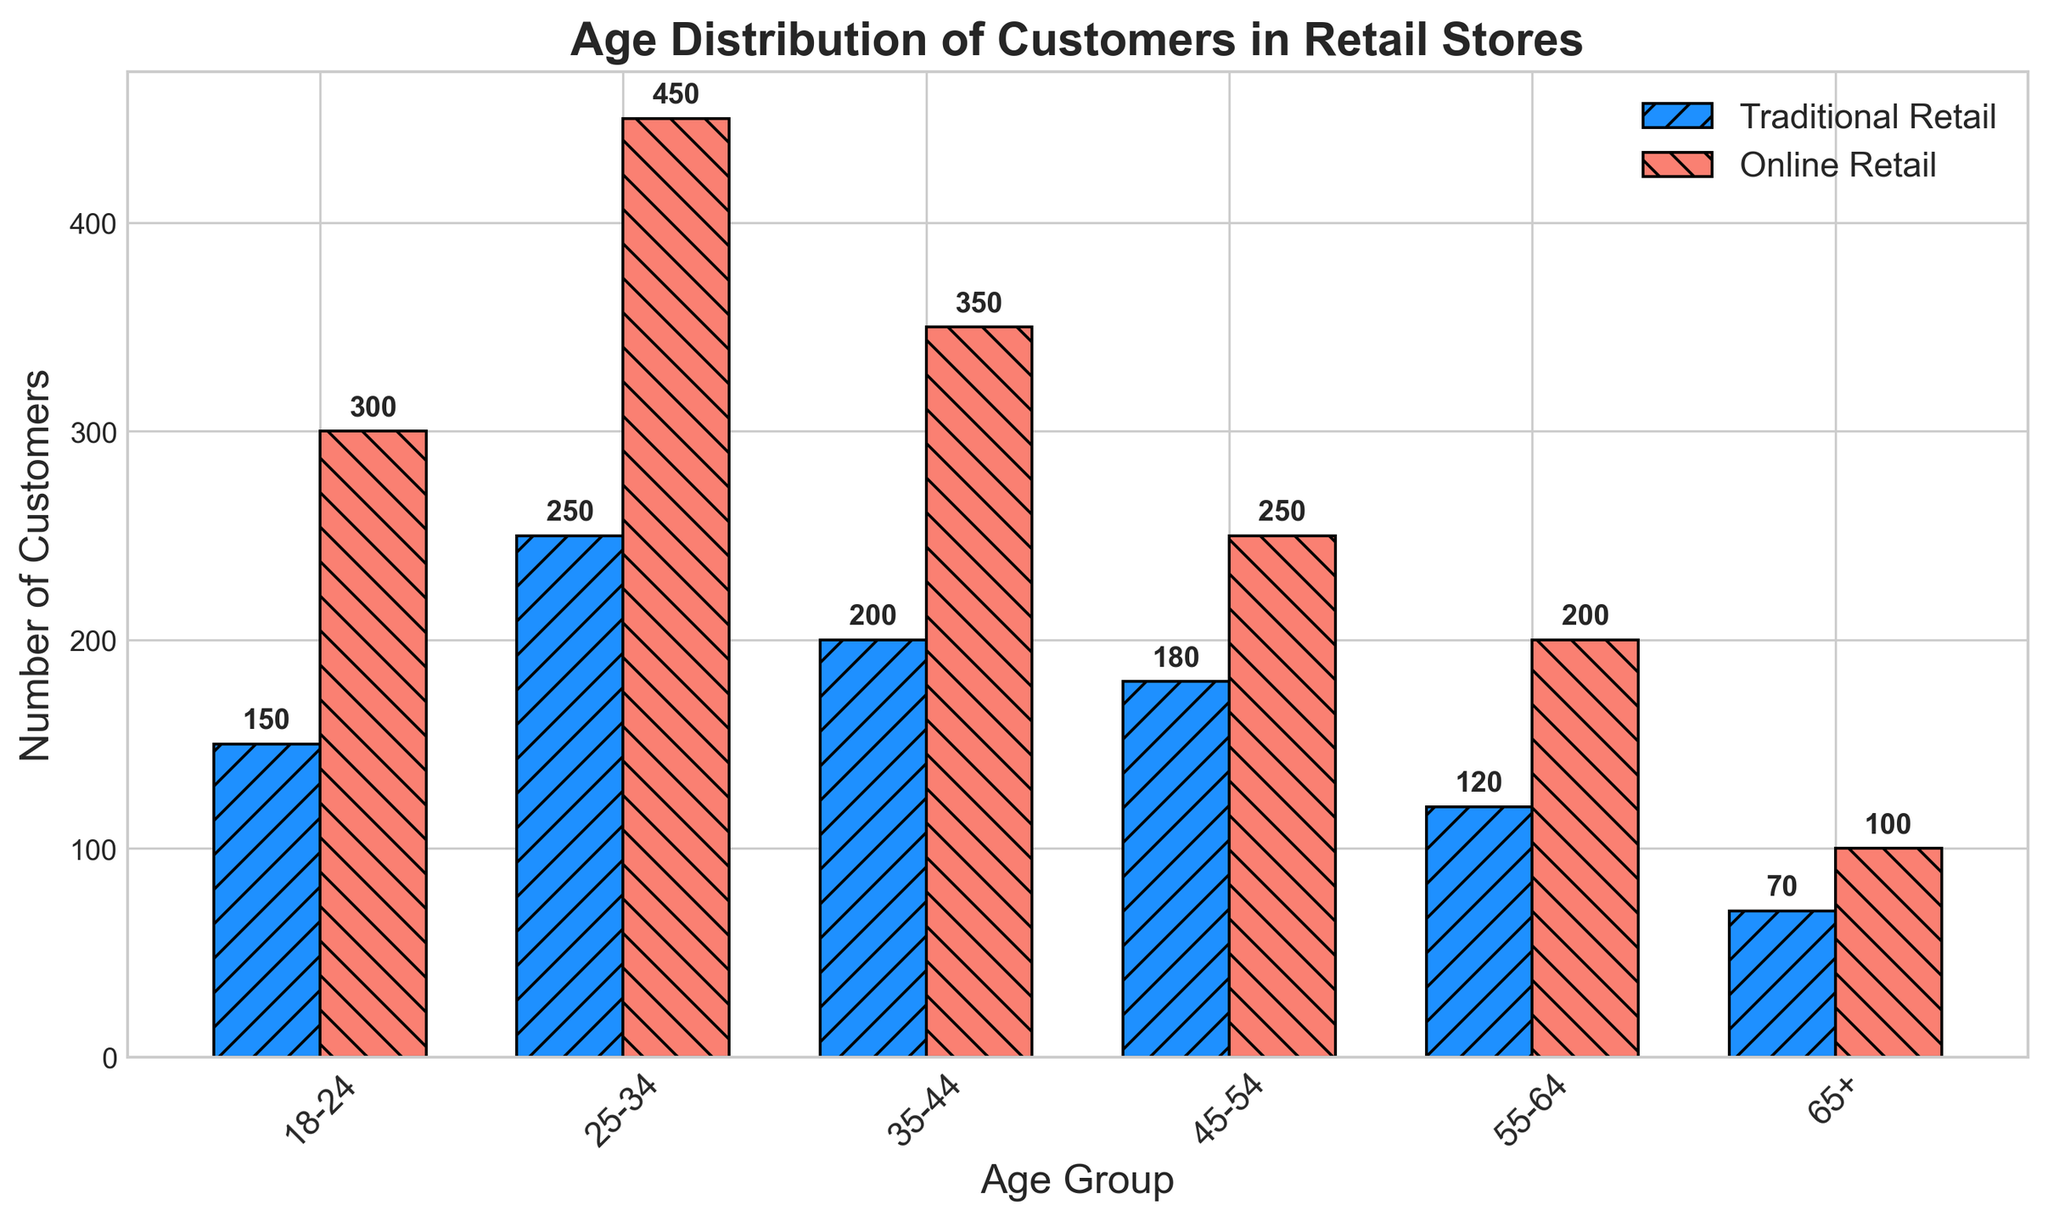What age group has the highest number of customers in traditional retail? Look at the height of the bars for Traditional Retail; the 25-34 age group is the highest.
Answer: 25-34 Which age group shows the smallest difference in number of customers between traditional retail and online retail? Subtract the number of customers in Traditional Retail from Online Retail for each age group. The smallest difference is in the 65+ group (100 - 70 = 30).
Answer: 65+ How many more customers aged 25-34 shop online compared to traditional retail? Subtract the number of 25-34 customers in Traditional Retail (250) from those in Online Retail (450).
Answer: 200 Which age group has the lowest number of customers in both traditional and online retail combined? Add the numbers for Traditional and Online Retail for each age group. The lowest sum is for the 65+ age group (70 + 100 = 170).
Answer: 65+ In which age group is traditional retail more popular than online retail? Compare the bars for each age group. In none of the age groups is traditional retail more popular than online retail.
Answer: None What is the difference in the number of customers between the age groups 35-44 and 55-64 for traditional retail? Subtract the number of 55-64 customers (120) from 35-44 customers (200).
Answer: 80 Compare the customer distribution in the 45-54 age group for traditional and online retail. Which one has more customers? Look at the height of the bars in the 45-54 age group; Online Retail has more customers (250) compared to Traditional Retail (180).
Answer: Online Retail How many total customers in traditional retail are aged under 35? Add the number of customers aged 18-24 (150) and 25-34 (250).
Answer: 400 Which age group shows the largest variance in height between the two types of bars? Observe the differences in bar heights for each age group. The 25-34 age group has the largest variance (450 - 250 = 200).
Answer: 25-34 Are there more traditional retail customers aged 45+ compared to online retail customers aged 18-24? Add traditional retail customers aged 45-54 (180), 55-64 (120), and 65+ (70) and compare to online retail customers aged 18-24 (300). Traditional retail customers aged 45+ sum to 370, while online retail customers aged 18-24 is 300.
Answer: Yes 